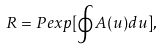<formula> <loc_0><loc_0><loc_500><loc_500>R = P e x p [ \oint A ( u ) d u ] ,</formula> 